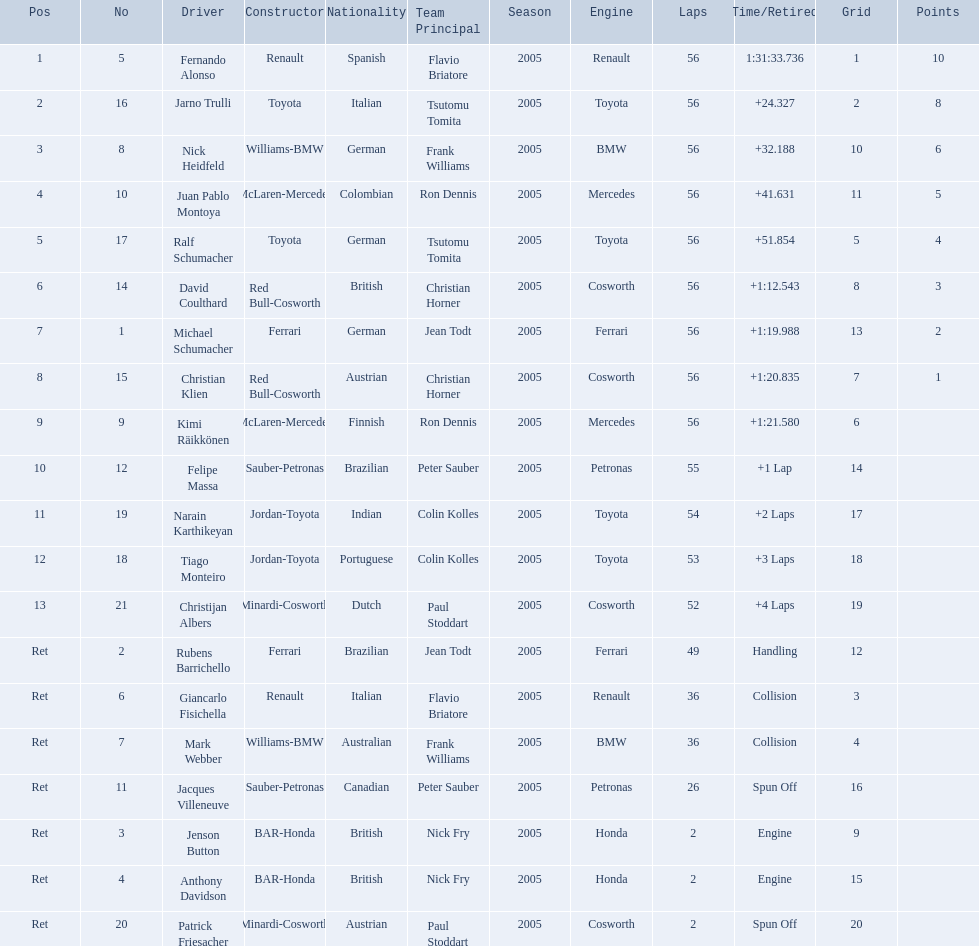Who was fernando alonso's instructor? Renault. How many laps did fernando alonso run? 56. How long did it take alonso to complete the race? 1:31:33.736. 